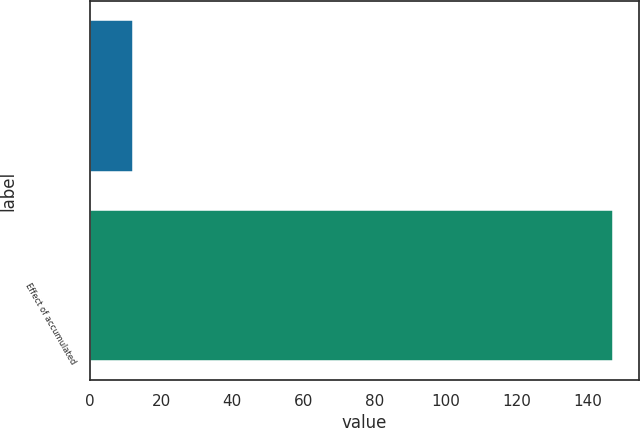Convert chart to OTSL. <chart><loc_0><loc_0><loc_500><loc_500><bar_chart><ecel><fcel>Effect of accumulated<nl><fcel>12<fcel>147<nl></chart> 